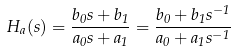<formula> <loc_0><loc_0><loc_500><loc_500>H _ { a } ( s ) = { \frac { b _ { 0 } s + b _ { 1 } } { a _ { 0 } s + a _ { 1 } } } = { \frac { b _ { 0 } + b _ { 1 } s ^ { - 1 } } { a _ { 0 } + a _ { 1 } s ^ { - 1 } } }</formula> 